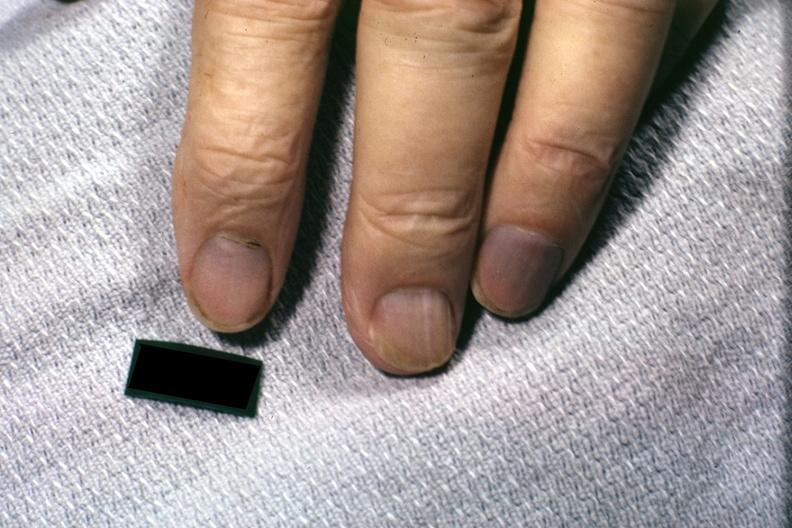what does this image show?
Answer the question using a single word or phrase. Excellent example of cyanotic nail beds 